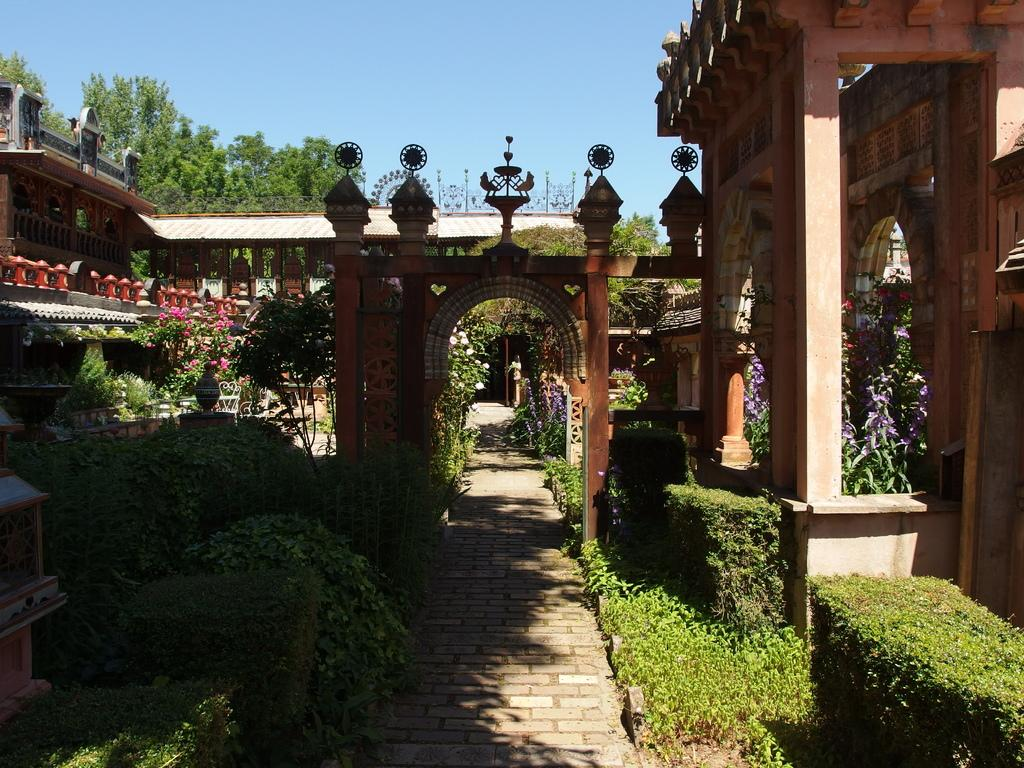What type of structures can be seen in the image? There are houses in the image. What type of vegetation is present in the image? There are trees and plants in the image. What is special about the plants in the image? The plants have colorful flowers. How many goldfish are swimming in the pond in the image? There is no pond or goldfish present in the image. What type of humor can be seen in the image? There is no humor depicted in the image; it features houses, trees, plants, and colorful flowers. 